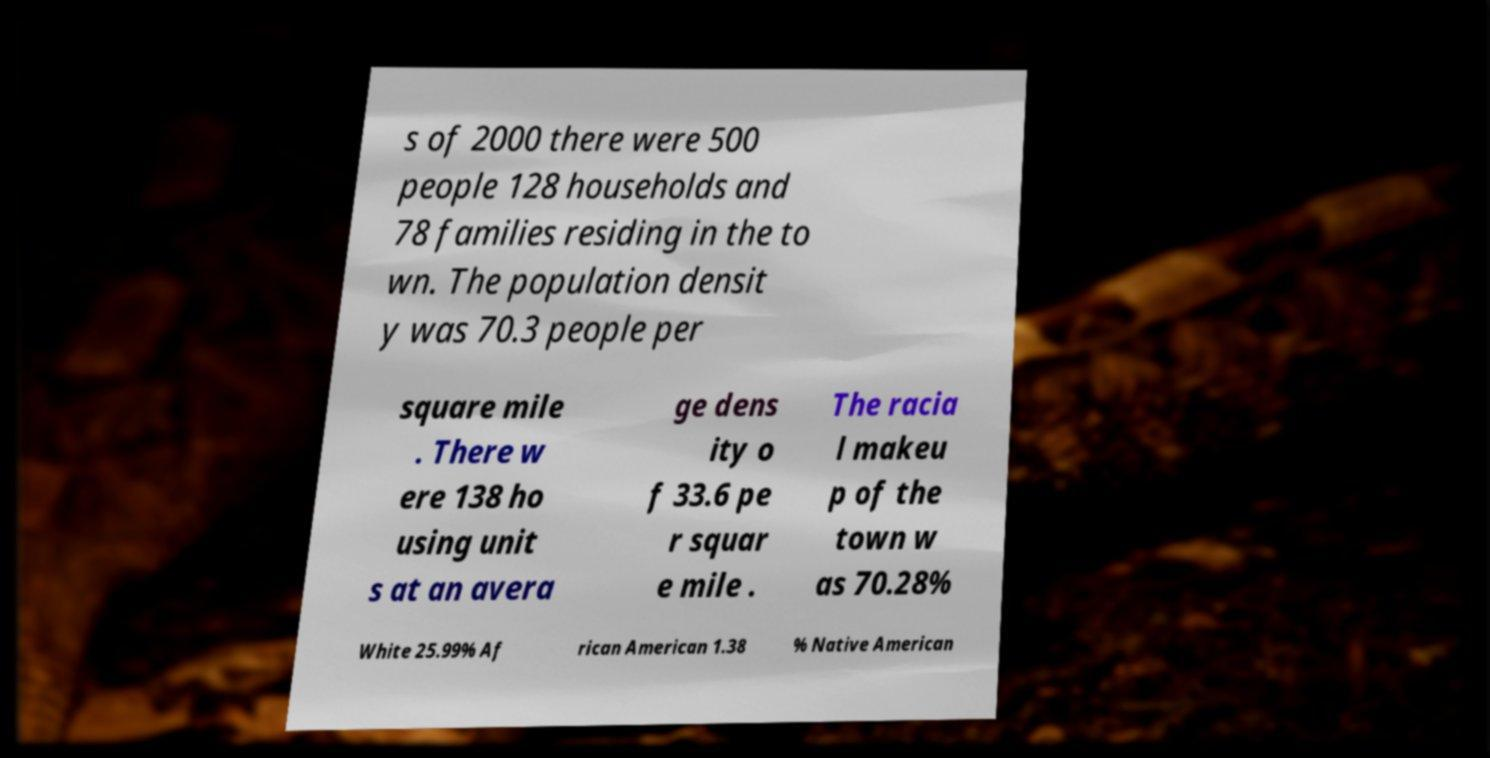Can you read and provide the text displayed in the image?This photo seems to have some interesting text. Can you extract and type it out for me? s of 2000 there were 500 people 128 households and 78 families residing in the to wn. The population densit y was 70.3 people per square mile . There w ere 138 ho using unit s at an avera ge dens ity o f 33.6 pe r squar e mile . The racia l makeu p of the town w as 70.28% White 25.99% Af rican American 1.38 % Native American 